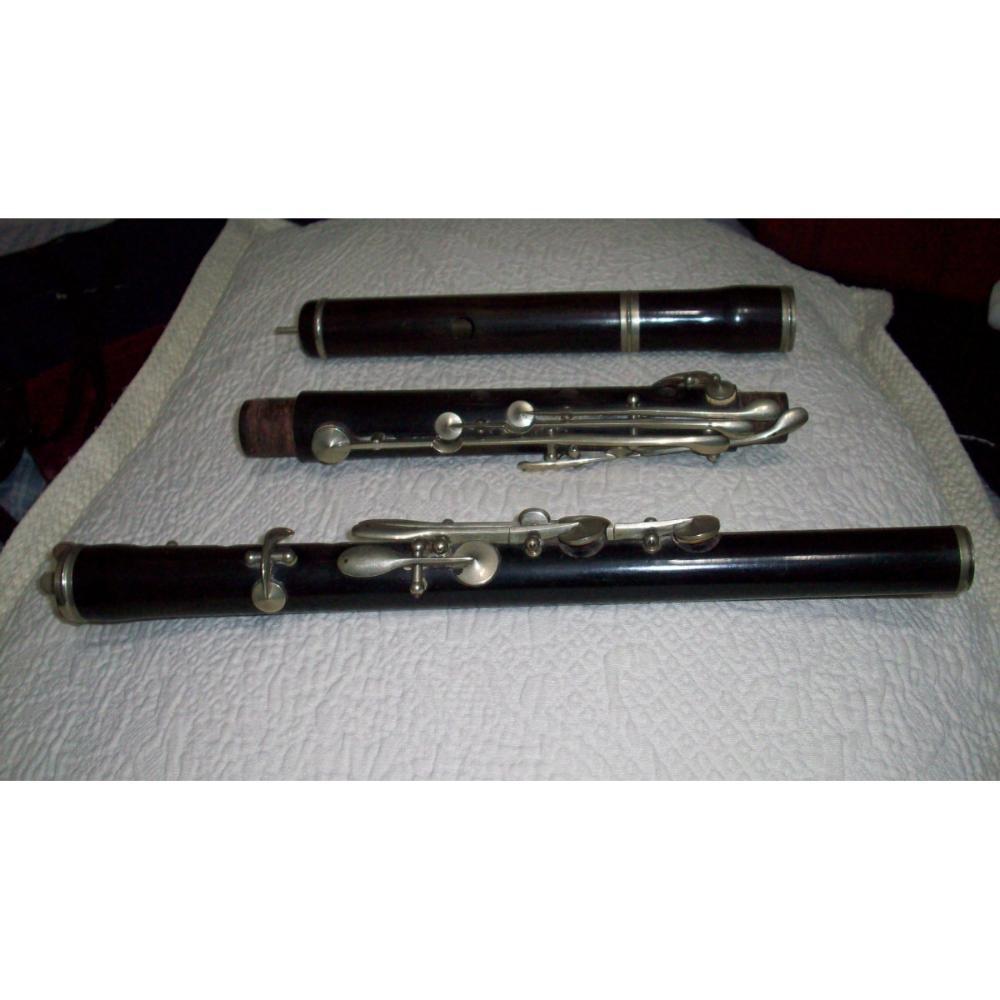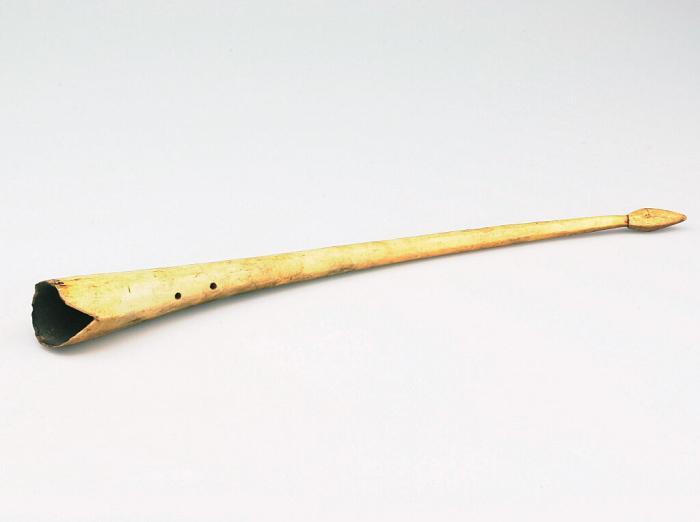The first image is the image on the left, the second image is the image on the right. Analyze the images presented: Is the assertion "The clarinet in the image on the left is taken apart into pieces." valid? Answer yes or no. Yes. The first image is the image on the left, the second image is the image on the right. Given the left and right images, does the statement "The left image includes at least two black tube-shaped flute parts displayed horizontally but spaced apart." hold true? Answer yes or no. Yes. 